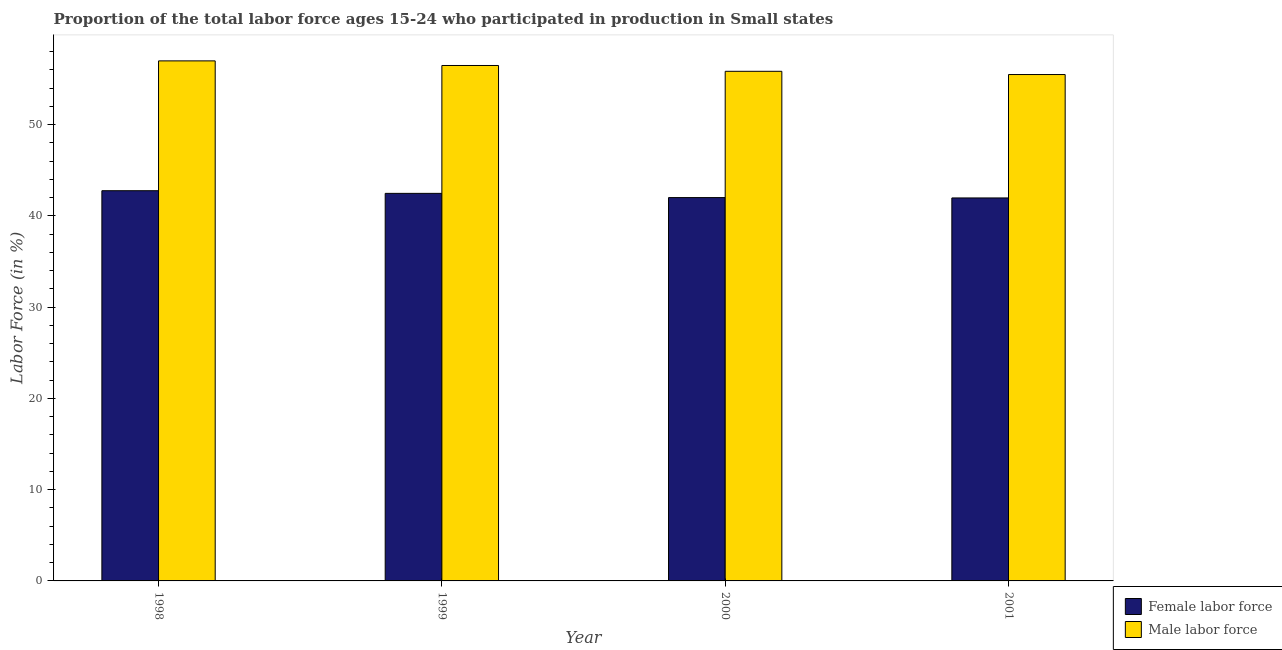How many different coloured bars are there?
Provide a short and direct response. 2. Are the number of bars per tick equal to the number of legend labels?
Provide a succinct answer. Yes. How many bars are there on the 2nd tick from the left?
Provide a succinct answer. 2. How many bars are there on the 2nd tick from the right?
Give a very brief answer. 2. What is the label of the 1st group of bars from the left?
Offer a terse response. 1998. What is the percentage of female labor force in 1999?
Give a very brief answer. 42.46. Across all years, what is the maximum percentage of male labour force?
Give a very brief answer. 56.98. Across all years, what is the minimum percentage of male labour force?
Give a very brief answer. 55.48. In which year was the percentage of male labour force maximum?
Your response must be concise. 1998. In which year was the percentage of male labour force minimum?
Offer a very short reply. 2001. What is the total percentage of male labour force in the graph?
Offer a very short reply. 224.78. What is the difference between the percentage of male labour force in 1999 and that in 2000?
Your answer should be compact. 0.64. What is the difference between the percentage of male labour force in 2000 and the percentage of female labor force in 1998?
Your answer should be very brief. -1.14. What is the average percentage of female labor force per year?
Make the answer very short. 42.3. What is the ratio of the percentage of male labour force in 1998 to that in 2000?
Offer a very short reply. 1.02. Is the difference between the percentage of female labor force in 1999 and 2000 greater than the difference between the percentage of male labour force in 1999 and 2000?
Your answer should be compact. No. What is the difference between the highest and the second highest percentage of female labor force?
Provide a succinct answer. 0.29. What is the difference between the highest and the lowest percentage of female labor force?
Ensure brevity in your answer.  0.79. What does the 1st bar from the left in 2001 represents?
Your answer should be very brief. Female labor force. What does the 1st bar from the right in 2000 represents?
Your answer should be very brief. Male labor force. How many bars are there?
Make the answer very short. 8. What is the difference between two consecutive major ticks on the Y-axis?
Give a very brief answer. 10. Does the graph contain grids?
Keep it short and to the point. No. Where does the legend appear in the graph?
Your answer should be very brief. Bottom right. How many legend labels are there?
Your response must be concise. 2. How are the legend labels stacked?
Ensure brevity in your answer.  Vertical. What is the title of the graph?
Your response must be concise. Proportion of the total labor force ages 15-24 who participated in production in Small states. Does "Working capital" appear as one of the legend labels in the graph?
Keep it short and to the point. No. What is the label or title of the X-axis?
Ensure brevity in your answer.  Year. What is the label or title of the Y-axis?
Keep it short and to the point. Labor Force (in %). What is the Labor Force (in %) in Female labor force in 1998?
Your response must be concise. 42.76. What is the Labor Force (in %) in Male labor force in 1998?
Give a very brief answer. 56.98. What is the Labor Force (in %) in Female labor force in 1999?
Your answer should be very brief. 42.46. What is the Labor Force (in %) in Male labor force in 1999?
Your answer should be very brief. 56.48. What is the Labor Force (in %) of Female labor force in 2000?
Ensure brevity in your answer.  42. What is the Labor Force (in %) in Male labor force in 2000?
Keep it short and to the point. 55.84. What is the Labor Force (in %) in Female labor force in 2001?
Provide a short and direct response. 41.96. What is the Labor Force (in %) in Male labor force in 2001?
Give a very brief answer. 55.48. Across all years, what is the maximum Labor Force (in %) of Female labor force?
Ensure brevity in your answer.  42.76. Across all years, what is the maximum Labor Force (in %) of Male labor force?
Make the answer very short. 56.98. Across all years, what is the minimum Labor Force (in %) of Female labor force?
Keep it short and to the point. 41.96. Across all years, what is the minimum Labor Force (in %) in Male labor force?
Offer a terse response. 55.48. What is the total Labor Force (in %) in Female labor force in the graph?
Your answer should be compact. 169.19. What is the total Labor Force (in %) of Male labor force in the graph?
Ensure brevity in your answer.  224.78. What is the difference between the Labor Force (in %) in Female labor force in 1998 and that in 1999?
Give a very brief answer. 0.29. What is the difference between the Labor Force (in %) of Male labor force in 1998 and that in 1999?
Provide a short and direct response. 0.51. What is the difference between the Labor Force (in %) of Female labor force in 1998 and that in 2000?
Offer a very short reply. 0.75. What is the difference between the Labor Force (in %) in Male labor force in 1998 and that in 2000?
Give a very brief answer. 1.14. What is the difference between the Labor Force (in %) in Female labor force in 1998 and that in 2001?
Ensure brevity in your answer.  0.79. What is the difference between the Labor Force (in %) of Male labor force in 1998 and that in 2001?
Make the answer very short. 1.5. What is the difference between the Labor Force (in %) of Female labor force in 1999 and that in 2000?
Keep it short and to the point. 0.46. What is the difference between the Labor Force (in %) in Male labor force in 1999 and that in 2000?
Provide a short and direct response. 0.64. What is the difference between the Labor Force (in %) of Female labor force in 1999 and that in 2001?
Your answer should be compact. 0.5. What is the difference between the Labor Force (in %) of Male labor force in 1999 and that in 2001?
Provide a short and direct response. 0.99. What is the difference between the Labor Force (in %) of Female labor force in 2000 and that in 2001?
Ensure brevity in your answer.  0.04. What is the difference between the Labor Force (in %) in Male labor force in 2000 and that in 2001?
Your response must be concise. 0.35. What is the difference between the Labor Force (in %) of Female labor force in 1998 and the Labor Force (in %) of Male labor force in 1999?
Give a very brief answer. -13.72. What is the difference between the Labor Force (in %) in Female labor force in 1998 and the Labor Force (in %) in Male labor force in 2000?
Your answer should be very brief. -13.08. What is the difference between the Labor Force (in %) in Female labor force in 1998 and the Labor Force (in %) in Male labor force in 2001?
Provide a short and direct response. -12.73. What is the difference between the Labor Force (in %) of Female labor force in 1999 and the Labor Force (in %) of Male labor force in 2000?
Ensure brevity in your answer.  -13.37. What is the difference between the Labor Force (in %) of Female labor force in 1999 and the Labor Force (in %) of Male labor force in 2001?
Keep it short and to the point. -13.02. What is the difference between the Labor Force (in %) of Female labor force in 2000 and the Labor Force (in %) of Male labor force in 2001?
Your answer should be very brief. -13.48. What is the average Labor Force (in %) of Female labor force per year?
Provide a succinct answer. 42.3. What is the average Labor Force (in %) of Male labor force per year?
Make the answer very short. 56.2. In the year 1998, what is the difference between the Labor Force (in %) in Female labor force and Labor Force (in %) in Male labor force?
Provide a succinct answer. -14.23. In the year 1999, what is the difference between the Labor Force (in %) in Female labor force and Labor Force (in %) in Male labor force?
Make the answer very short. -14.01. In the year 2000, what is the difference between the Labor Force (in %) in Female labor force and Labor Force (in %) in Male labor force?
Ensure brevity in your answer.  -13.84. In the year 2001, what is the difference between the Labor Force (in %) in Female labor force and Labor Force (in %) in Male labor force?
Your answer should be compact. -13.52. What is the ratio of the Labor Force (in %) of Female labor force in 1998 to that in 1999?
Your answer should be compact. 1.01. What is the ratio of the Labor Force (in %) of Female labor force in 1998 to that in 2000?
Ensure brevity in your answer.  1.02. What is the ratio of the Labor Force (in %) of Male labor force in 1998 to that in 2000?
Offer a very short reply. 1.02. What is the ratio of the Labor Force (in %) of Female labor force in 1998 to that in 2001?
Provide a succinct answer. 1.02. What is the ratio of the Labor Force (in %) of Male labor force in 1998 to that in 2001?
Ensure brevity in your answer.  1.03. What is the ratio of the Labor Force (in %) in Male labor force in 1999 to that in 2000?
Keep it short and to the point. 1.01. What is the ratio of the Labor Force (in %) in Female labor force in 1999 to that in 2001?
Keep it short and to the point. 1.01. What is the ratio of the Labor Force (in %) in Male labor force in 1999 to that in 2001?
Keep it short and to the point. 1.02. What is the ratio of the Labor Force (in %) in Male labor force in 2000 to that in 2001?
Offer a terse response. 1.01. What is the difference between the highest and the second highest Labor Force (in %) of Female labor force?
Offer a very short reply. 0.29. What is the difference between the highest and the second highest Labor Force (in %) in Male labor force?
Provide a succinct answer. 0.51. What is the difference between the highest and the lowest Labor Force (in %) of Female labor force?
Your response must be concise. 0.79. What is the difference between the highest and the lowest Labor Force (in %) of Male labor force?
Your answer should be compact. 1.5. 